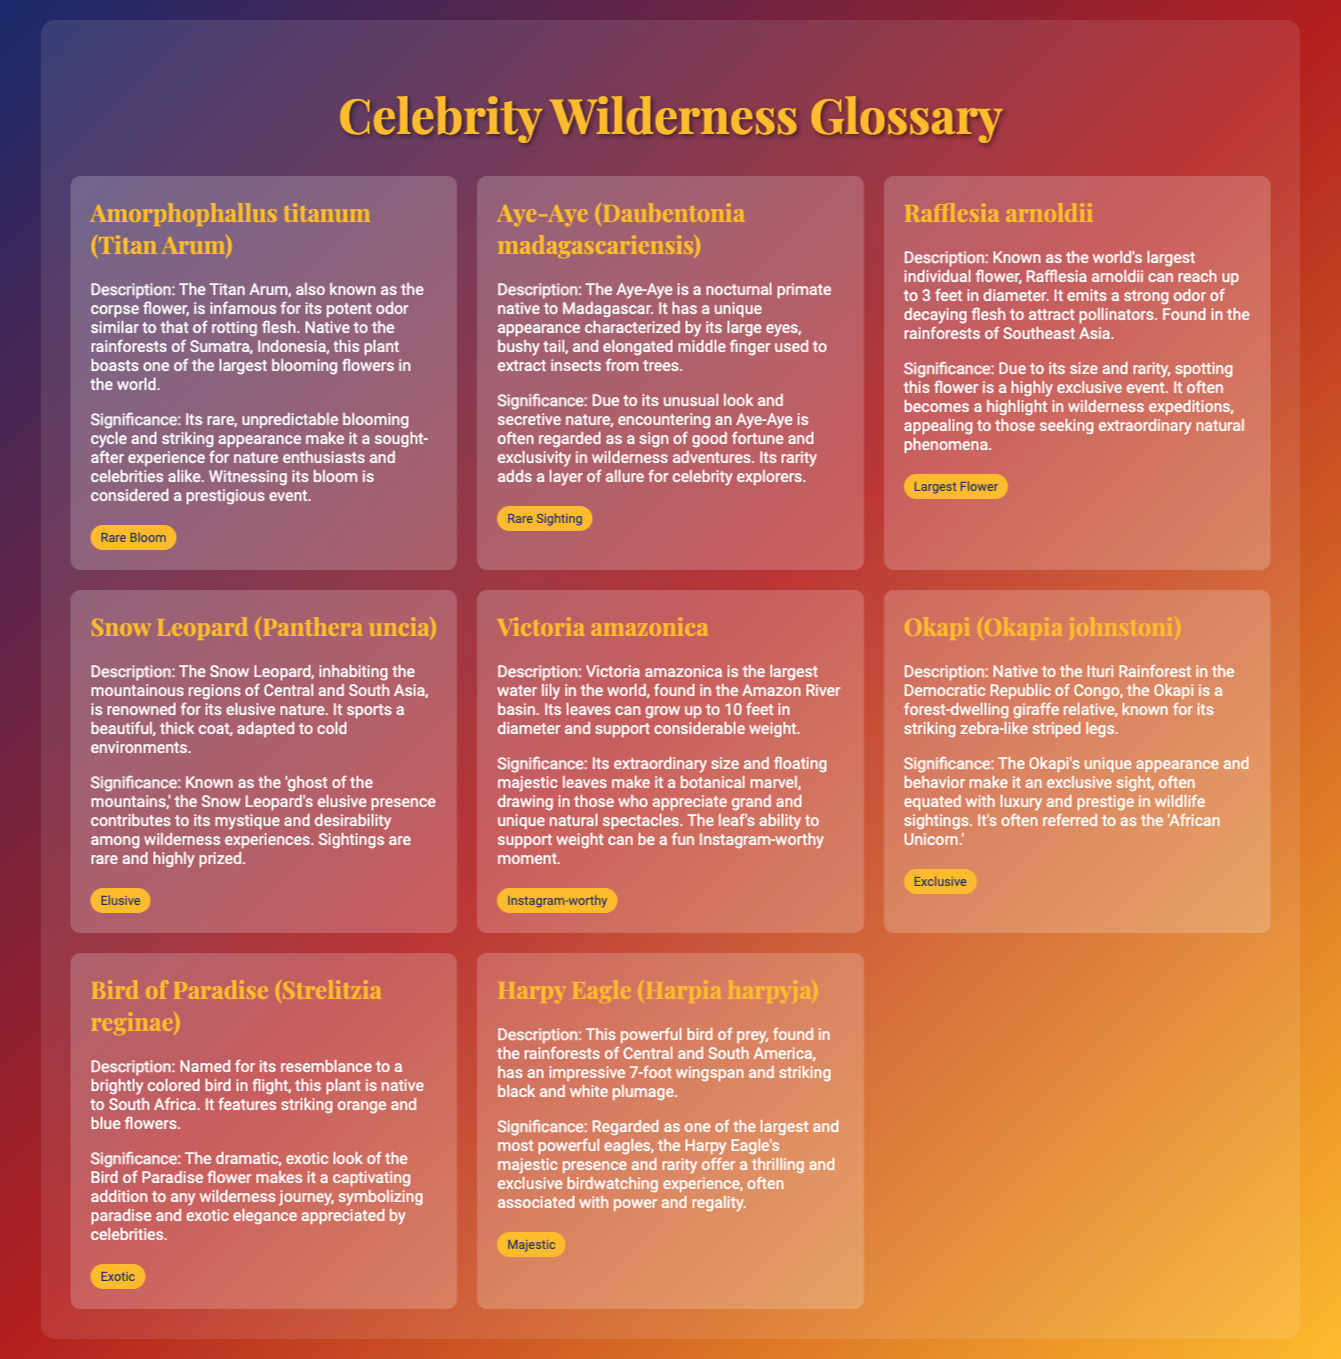what is the scientific name of the Titan Arum? The scientific name of the Titan Arum, known for its large blooming flower, is Amorphophallus titanum.
Answer: Amorphophallus titanum where is the Aye-Aye native to? The Aye-Aye is a nocturnal primate native to Madagascar.
Answer: Madagascar what is the nickname of the Snow Leopard? The Snow Leopard is often referred to as the 'ghost of the mountains' due to its elusive nature.
Answer: ghost of the mountains how many feet can Victoria amazonica leaves grow? Victoria amazonica leaves can grow up to 10 feet in diameter.
Answer: 10 feet which plant resembles a bird in flight? The Bird of Paradise is named for its resemblance to a brightly colored bird in flight.
Answer: Bird of Paradise what is the significance of Rafflesia arnoldii? The significance of Rafflesia arnoldii lies in its size and rarity, making spotting this flower a highly exclusive event.
Answer: highly exclusive event which animal is referred to as the 'African Unicorn'? The Okapi is often referred to as the 'African Unicorn' due to its unique appearance and behavior.
Answer: Okapi what is the wingspan of the Harpy Eagle? The Harpy Eagle has an impressive wingspan of 7 feet.
Answer: 7 feet 